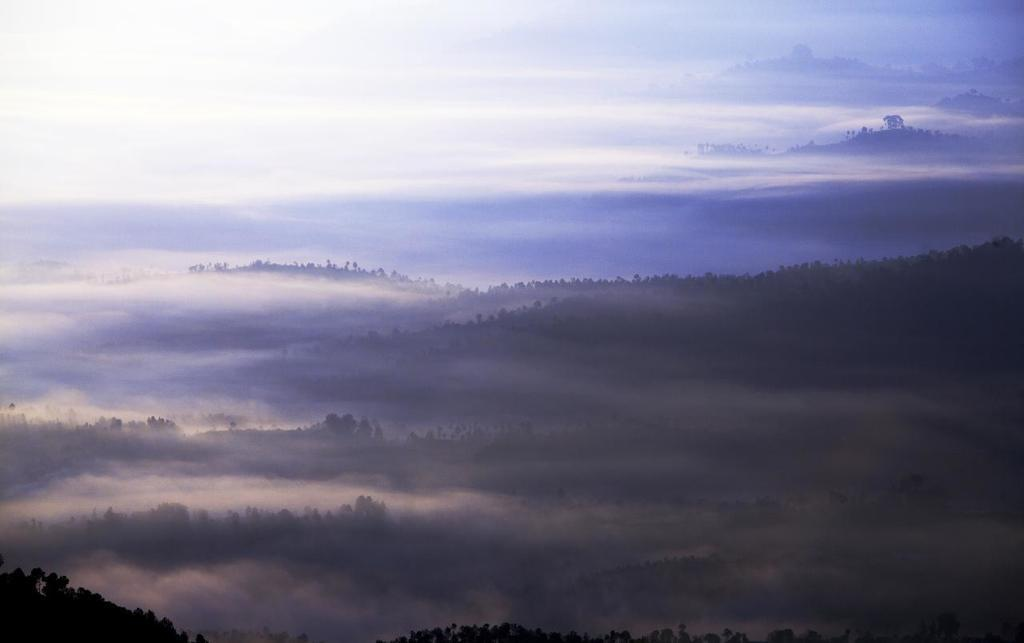What type of vegetation can be seen in the image? There are trees in the image. What part of the natural environment is visible in the image? The sky is visible in the image. What grade does the tree receive in the image? There is no grade assigned to the tree in the image, as trees do not receive grades. 